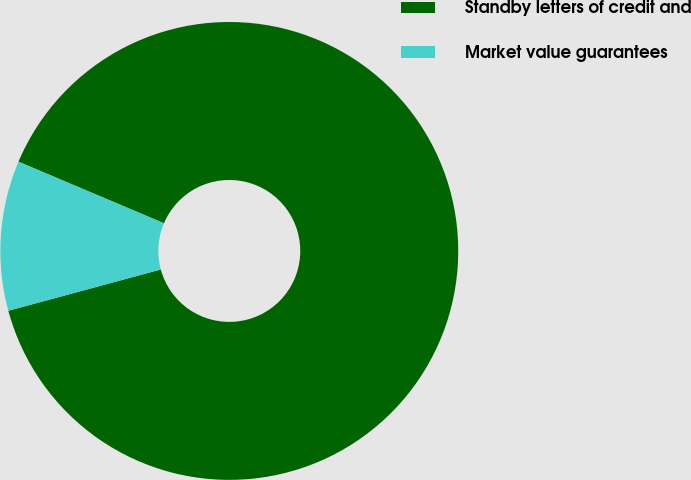Convert chart. <chart><loc_0><loc_0><loc_500><loc_500><pie_chart><fcel>Standby letters of credit and<fcel>Market value guarantees<nl><fcel>89.42%<fcel>10.58%<nl></chart> 